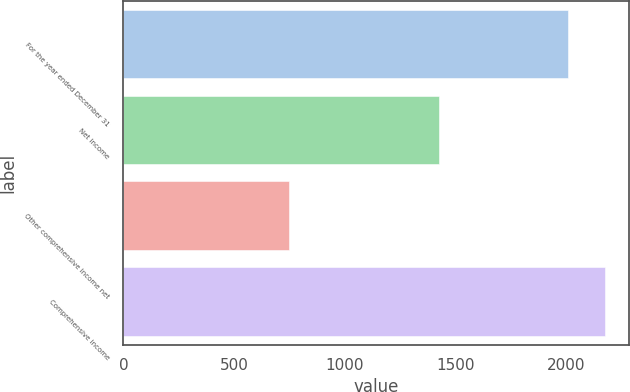Convert chart to OTSL. <chart><loc_0><loc_0><loc_500><loc_500><bar_chart><fcel>For the year ended December 31<fcel>Net income<fcel>Other comprehensive income net<fcel>Comprehensive income<nl><fcel>2011<fcel>1426<fcel>750<fcel>2176<nl></chart> 